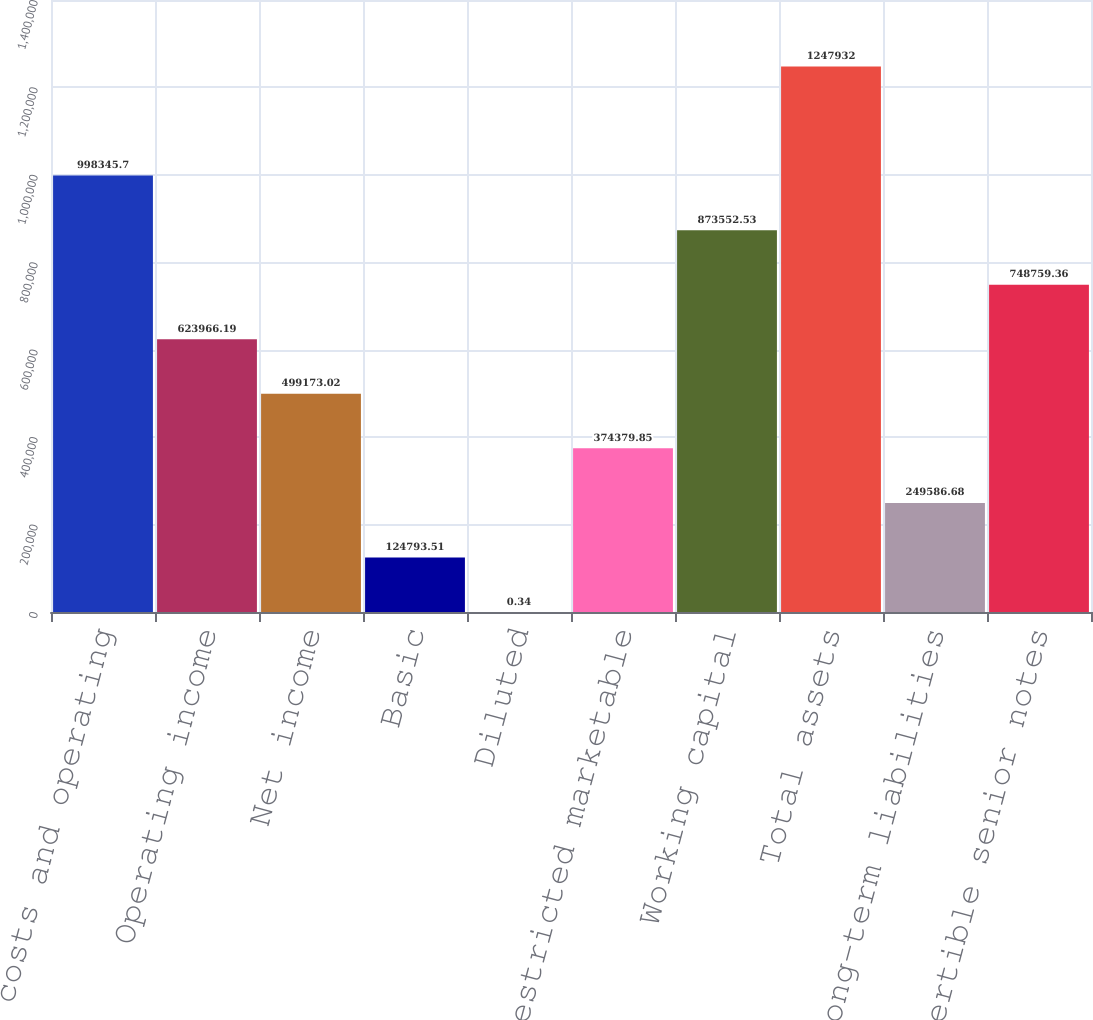<chart> <loc_0><loc_0><loc_500><loc_500><bar_chart><fcel>Total costs and operating<fcel>Operating income<fcel>Net income<fcel>Basic<fcel>Diluted<fcel>Restricted marketable<fcel>Working capital<fcel>Total assets<fcel>Other long-term liabilities<fcel>1 convertible senior notes<nl><fcel>998346<fcel>623966<fcel>499173<fcel>124794<fcel>0.34<fcel>374380<fcel>873553<fcel>1.24793e+06<fcel>249587<fcel>748759<nl></chart> 